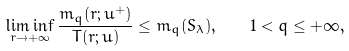Convert formula to latex. <formula><loc_0><loc_0><loc_500><loc_500>\liminf _ { r \to + \infty } \frac { m _ { q } ( r ; u ^ { + } ) } { T ( r ; u ) } \leq m _ { q } ( S _ { \lambda } ) , \quad 1 < q \leq + \infty ,</formula> 